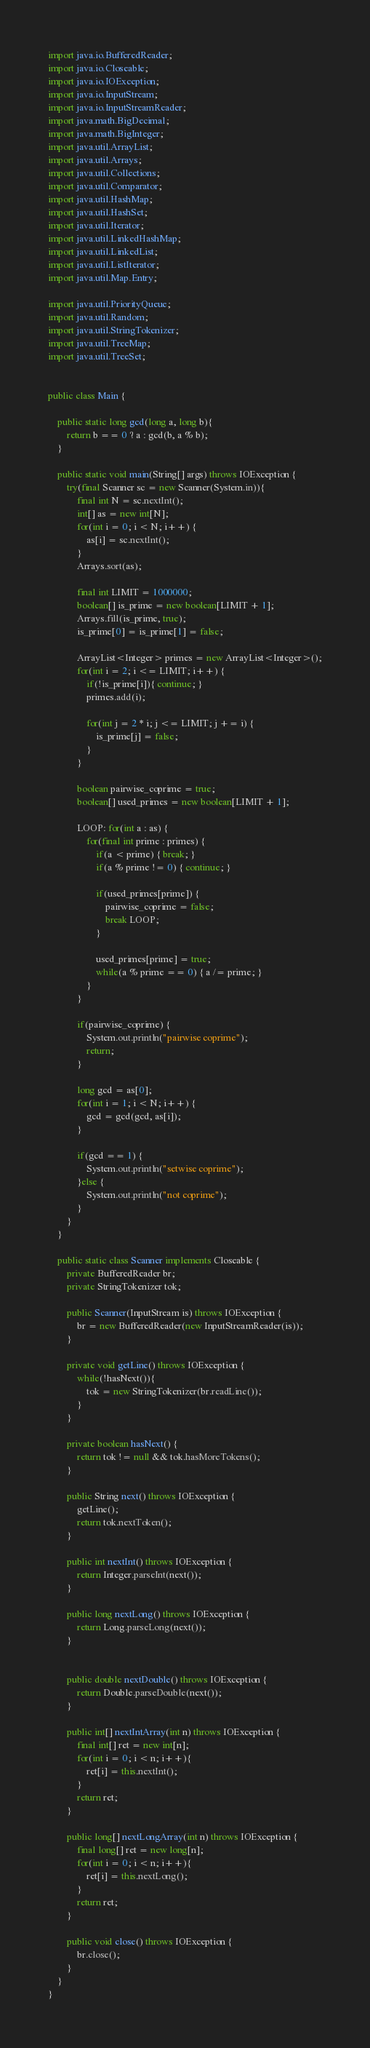Convert code to text. <code><loc_0><loc_0><loc_500><loc_500><_Java_>import java.io.BufferedReader;
import java.io.Closeable;
import java.io.IOException;
import java.io.InputStream;
import java.io.InputStreamReader;
import java.math.BigDecimal;
import java.math.BigInteger;
import java.util.ArrayList;
import java.util.Arrays;
import java.util.Collections;
import java.util.Comparator;
import java.util.HashMap;
import java.util.HashSet;
import java.util.Iterator;
import java.util.LinkedHashMap;
import java.util.LinkedList;
import java.util.ListIterator;
import java.util.Map.Entry;

import java.util.PriorityQueue;
import java.util.Random;
import java.util.StringTokenizer;
import java.util.TreeMap;
import java.util.TreeSet;


public class Main {
	
	public static long gcd(long a, long b){
		return b == 0 ? a : gcd(b, a % b);
	}
	
	public static void main(String[] args) throws IOException {	
		try(final Scanner sc = new Scanner(System.in)){
			final int N = sc.nextInt();
			int[] as = new int[N];
			for(int i = 0; i < N; i++) {
				as[i] = sc.nextInt();
			}
			Arrays.sort(as);
			
			final int LIMIT = 1000000;
			boolean[] is_prime = new boolean[LIMIT + 1];
			Arrays.fill(is_prime, true);
			is_prime[0] = is_prime[1] = false;
			
			ArrayList<Integer> primes = new ArrayList<Integer>();
			for(int i = 2; i <= LIMIT; i++) {
				if(!is_prime[i]){ continue; }
				primes.add(i);
				
				for(int j = 2 * i; j <= LIMIT; j += i) {
					is_prime[j] = false;
				}
			}
			
			boolean pairwise_coprime = true;
			boolean[] used_primes = new boolean[LIMIT + 1];

			LOOP: for(int a : as) {
				for(final int prime : primes) {
					if(a < prime) { break; }
					if(a % prime != 0) { continue; }
					
					if(used_primes[prime]) {
						pairwise_coprime = false;
						break LOOP;
					}
					
					used_primes[prime] = true;
					while(a % prime == 0) { a /= prime; }
				}
			}
			
			if(pairwise_coprime) {
				System.out.println("pairwise coprime");
				return;
			}
			
			long gcd = as[0];
			for(int i = 1; i < N; i++) {
				gcd = gcd(gcd, as[i]);
			}
			
			if(gcd == 1) {
				System.out.println("setwise coprime");
			}else {
				System.out.println("not coprime");
			}
		}
	}

	public static class Scanner implements Closeable {
		private BufferedReader br;
		private StringTokenizer tok;

		public Scanner(InputStream is) throws IOException {
			br = new BufferedReader(new InputStreamReader(is));
		}

		private void getLine() throws IOException {
			while(!hasNext()){
				tok = new StringTokenizer(br.readLine());
			}
		}

		private boolean hasNext() {
			return tok != null && tok.hasMoreTokens();
		}

		public String next() throws IOException {
			getLine();
			return tok.nextToken();
		}

		public int nextInt() throws IOException {
			return Integer.parseInt(next());
		}

		public long nextLong() throws IOException {
			return Long.parseLong(next());
		}
		

		public double nextDouble() throws IOException {
			return Double.parseDouble(next());
		}

		public int[] nextIntArray(int n) throws IOException {
			final int[] ret = new int[n];
			for(int i = 0; i < n; i++){
				ret[i] = this.nextInt();
			}
			return ret;
		}

		public long[] nextLongArray(int n) throws IOException {
			final long[] ret = new long[n];
			for(int i = 0; i < n; i++){
				ret[i] = this.nextLong();
			}
			return ret;
		}

		public void close() throws IOException {
			br.close();
		}
	}
}
</code> 